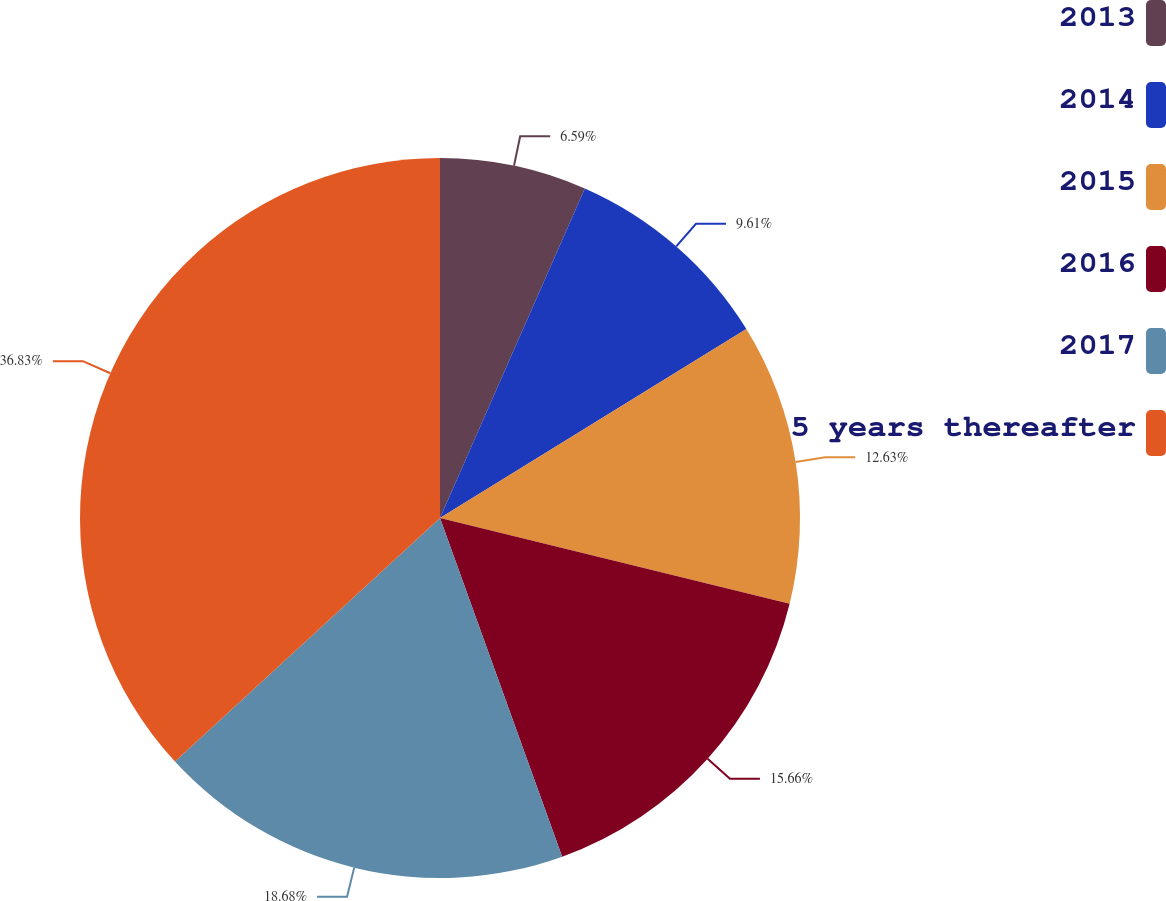<chart> <loc_0><loc_0><loc_500><loc_500><pie_chart><fcel>2013<fcel>2014<fcel>2015<fcel>2016<fcel>2017<fcel>5 years thereafter<nl><fcel>6.59%<fcel>9.61%<fcel>12.63%<fcel>15.66%<fcel>18.68%<fcel>36.83%<nl></chart> 